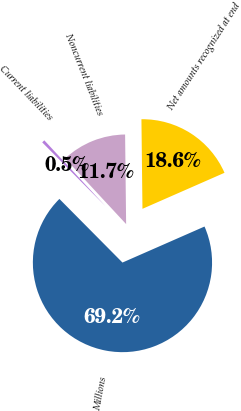<chart> <loc_0><loc_0><loc_500><loc_500><pie_chart><fcel>Millions<fcel>Current liabilities<fcel>Noncurrent liabilities<fcel>Net amounts recognized at end<nl><fcel>69.16%<fcel>0.52%<fcel>11.73%<fcel>18.6%<nl></chart> 